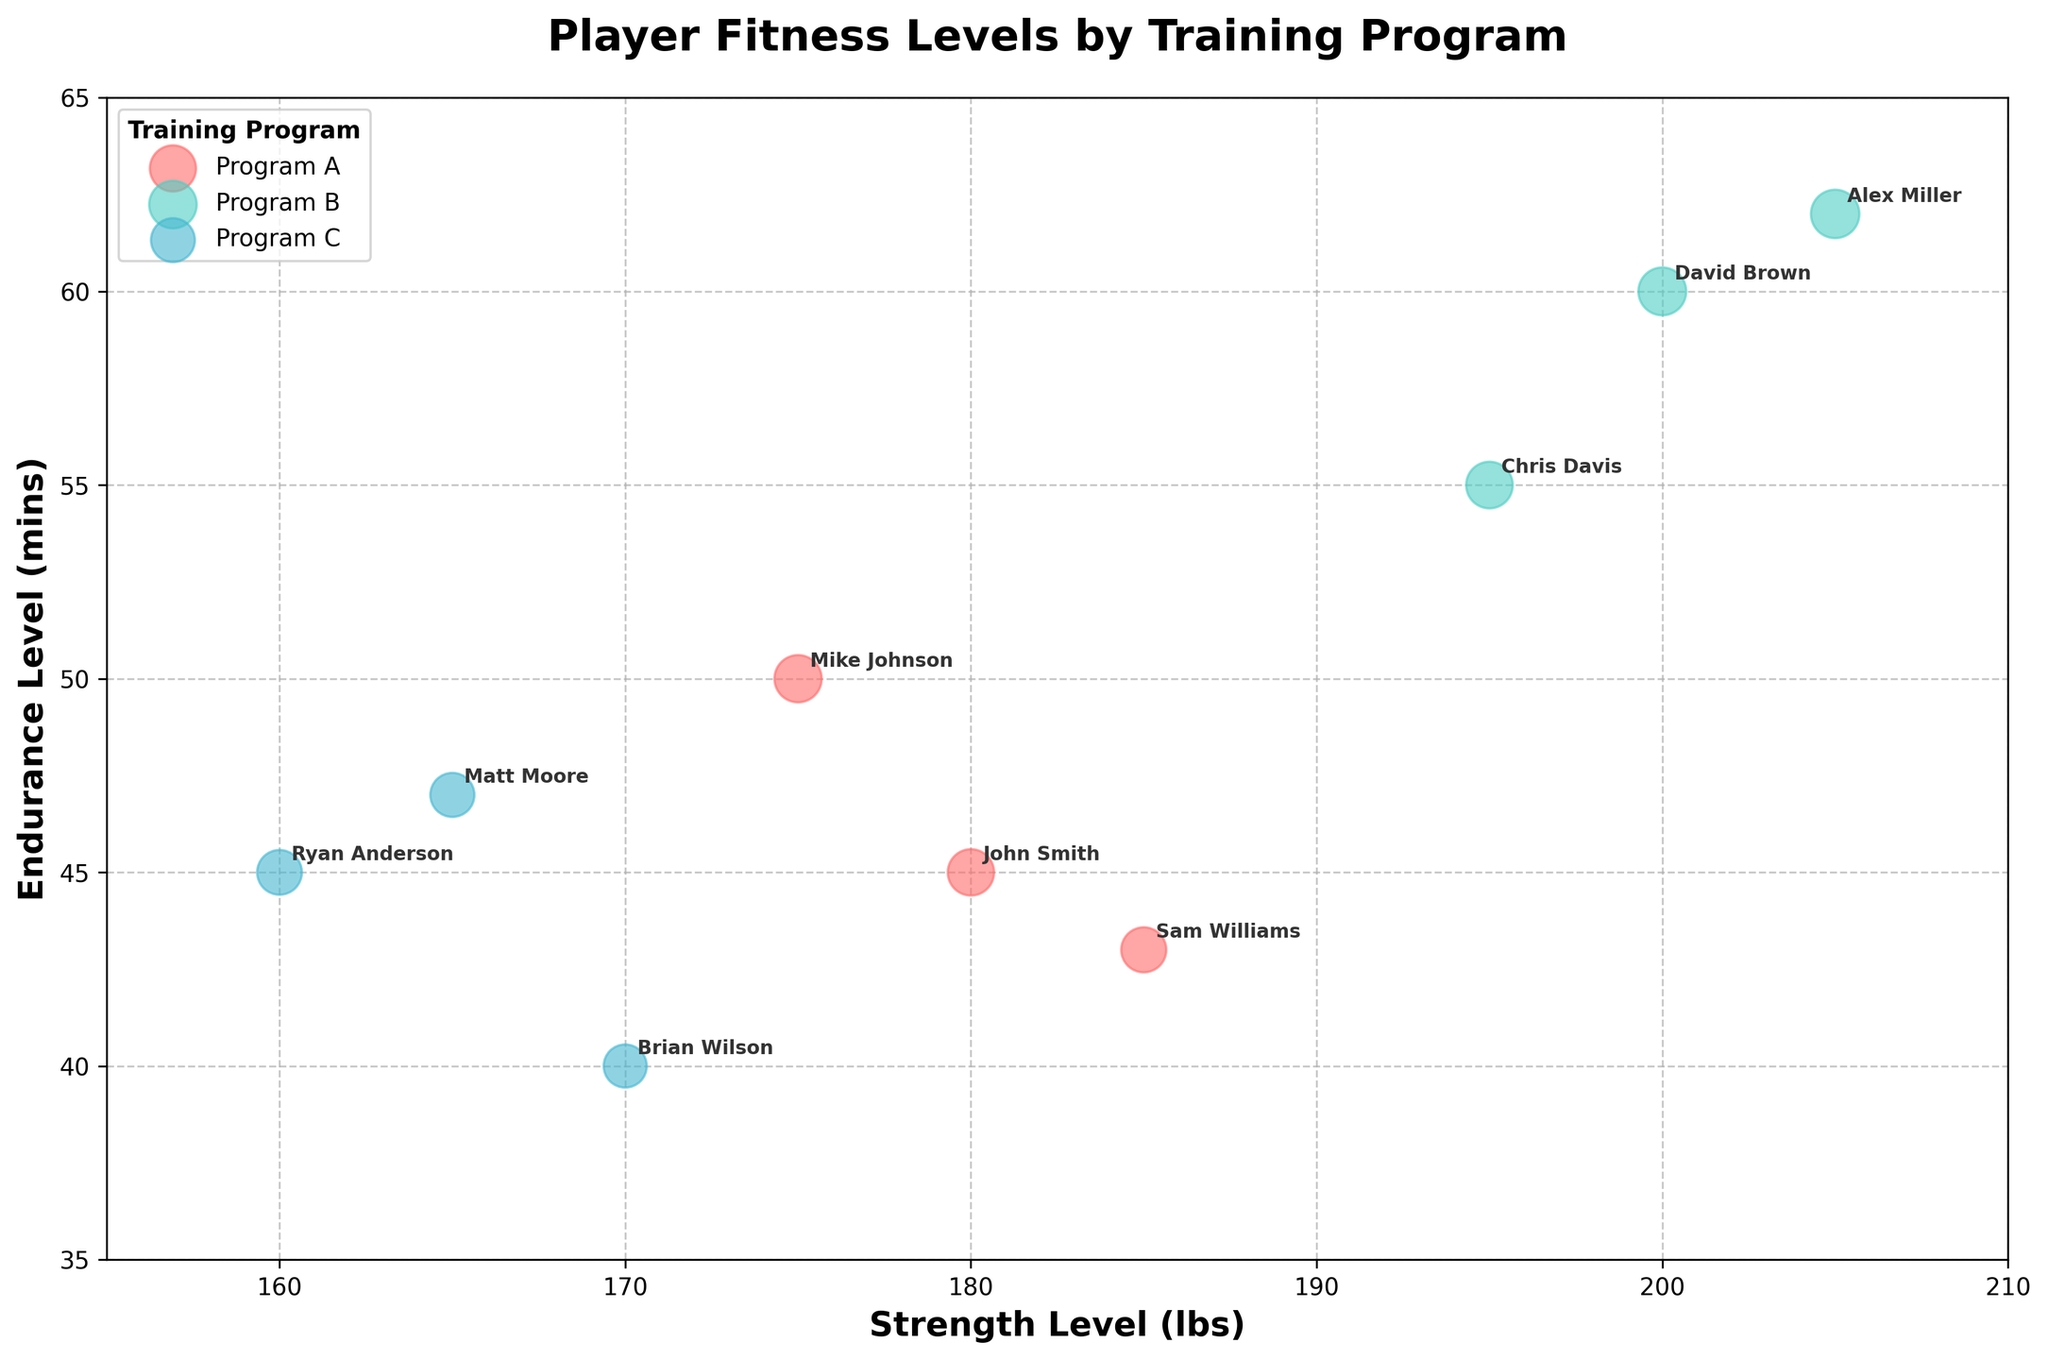What is the title of the chart? The title is displayed at the top-center of the chart, in bold font. It reads: "Player Fitness Levels by Training Program".
Answer: Player Fitness Levels by Training Program What do the x and y axes represent? The x-axis represents "Strength Level (lbs)" and the y-axis represents "Endurance Level (mins)". These labels are indicated at the bottom and left side of the chart respectively, both in bold font.
Answer: Strength Level (lbs) and Endurance Level (mins) How many injury incidents does Alex Miller have? Alex Miller's data point can be found by locating the label "Alex Miller" on the chart. Next, check the bubble size and transparency associated with Alex Miller’s data point to infer the number of injury incidents.
Answer: 0 Which training program has the player with the highest endurance level? Find the tallest data point along the y-axis (Endurance Level) and identify its associated player's name and training program by following the label near the data point.
Answer: Program B Which player belongs to Program C and has the highest strength level? Locate the data points labeled with Program C and check the values on the x-axis (Strength Level). Identify the player with the highest x-axis value in Program C.
Answer: Brian Wilson Which training program has the highest average speed level? Determine the speed levels of all players in each program (e.g., Program A: 7.5, 7.8, 7.1). Calculate the average speed for each program and compare them. For Program A: (7.5 + 7.8 + 7.1) / 3 = 7.47, For Program B: (8.0 + 7.6 + 8.2) / 3 = 7.93, For Program C: (6.5 + 6.8 + 7.0) / 3 = 6.77.
Answer: Program B Out of all the training programs, which specific player has the lowest endurance level? Locate the data point closest to the bottom of the y-axis (Endurance Level) and identify the player's name from the label next to the data point.
Answer: Brian Wilson What's the average strength level of the players in Program B? Calculate the sum of all strength levels in Program B, then divide by the number of players in Program B. Sum: (200 + 195 + 205) = 600; Number of players = 3; Average = 600 / 3 = 200.
Answer: 200 Which program has the most diverse range of endurance levels? Compare the range (maximum - minimum) of endurance levels in each program. For Program A: max 50, min 43, range = 50 - 43 = 7; For Program B: max 62, min 55, range = 62 - 55 = 7; For Program C: max 47, min 40, range = 47 - 40 = 7. Evaluate which program has the greatest difference in values.
Answer: All have a range of 7 Who are the players with over 50 minutes of endurance in different programs? Scan for data points with an endurance level (y-axis) over 50 mins and note their associated labels and programs.
Answer: Mike Johnson, David Brown, Alex Miller 